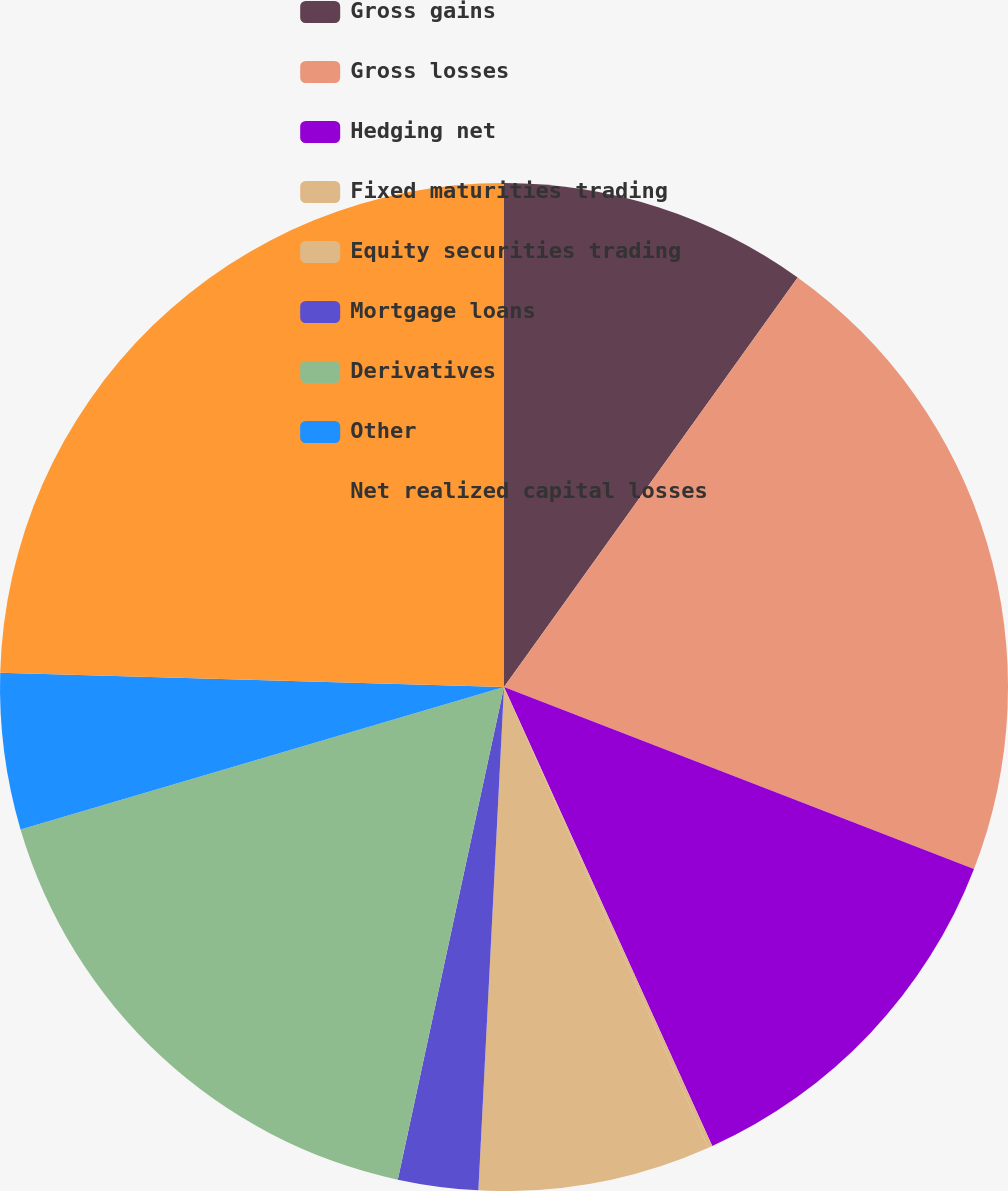<chart> <loc_0><loc_0><loc_500><loc_500><pie_chart><fcel>Gross gains<fcel>Gross losses<fcel>Hedging net<fcel>Fixed maturities trading<fcel>Equity securities trading<fcel>Mortgage loans<fcel>Derivatives<fcel>Other<fcel>Net realized capital losses<nl><fcel>9.9%<fcel>20.98%<fcel>12.34%<fcel>0.13%<fcel>7.46%<fcel>2.57%<fcel>17.06%<fcel>5.01%<fcel>24.55%<nl></chart> 